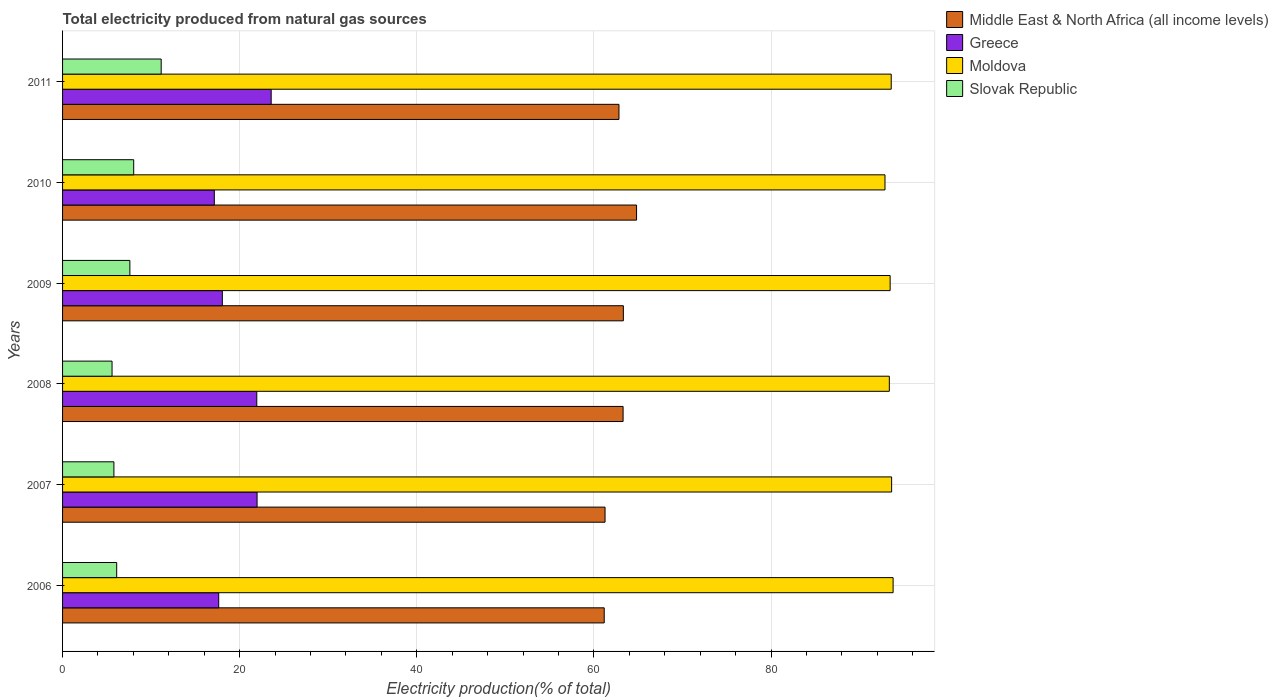How many different coloured bars are there?
Your answer should be very brief. 4. Are the number of bars per tick equal to the number of legend labels?
Your response must be concise. Yes. How many bars are there on the 3rd tick from the top?
Keep it short and to the point. 4. How many bars are there on the 1st tick from the bottom?
Your answer should be compact. 4. In how many cases, is the number of bars for a given year not equal to the number of legend labels?
Your answer should be compact. 0. What is the total electricity produced in Slovak Republic in 2006?
Your answer should be very brief. 6.11. Across all years, what is the maximum total electricity produced in Moldova?
Offer a terse response. 93.78. Across all years, what is the minimum total electricity produced in Middle East & North Africa (all income levels)?
Make the answer very short. 61.16. In which year was the total electricity produced in Greece maximum?
Keep it short and to the point. 2011. In which year was the total electricity produced in Middle East & North Africa (all income levels) minimum?
Your response must be concise. 2006. What is the total total electricity produced in Slovak Republic in the graph?
Your answer should be very brief. 44.27. What is the difference between the total electricity produced in Greece in 2007 and that in 2009?
Provide a succinct answer. 3.92. What is the difference between the total electricity produced in Moldova in 2006 and the total electricity produced in Middle East & North Africa (all income levels) in 2008?
Your response must be concise. 30.49. What is the average total electricity produced in Middle East & North Africa (all income levels) per year?
Offer a terse response. 62.78. In the year 2010, what is the difference between the total electricity produced in Greece and total electricity produced in Moldova?
Give a very brief answer. -75.73. What is the ratio of the total electricity produced in Greece in 2006 to that in 2007?
Ensure brevity in your answer.  0.8. Is the difference between the total electricity produced in Greece in 2007 and 2010 greater than the difference between the total electricity produced in Moldova in 2007 and 2010?
Offer a very short reply. Yes. What is the difference between the highest and the second highest total electricity produced in Middle East & North Africa (all income levels)?
Your response must be concise. 1.49. What is the difference between the highest and the lowest total electricity produced in Moldova?
Provide a short and direct response. 0.92. In how many years, is the total electricity produced in Middle East & North Africa (all income levels) greater than the average total electricity produced in Middle East & North Africa (all income levels) taken over all years?
Offer a very short reply. 4. Is the sum of the total electricity produced in Greece in 2006 and 2008 greater than the maximum total electricity produced in Slovak Republic across all years?
Your answer should be compact. Yes. Is it the case that in every year, the sum of the total electricity produced in Middle East & North Africa (all income levels) and total electricity produced in Moldova is greater than the sum of total electricity produced in Slovak Republic and total electricity produced in Greece?
Provide a succinct answer. No. What does the 1st bar from the top in 2010 represents?
Offer a terse response. Slovak Republic. What does the 1st bar from the bottom in 2007 represents?
Your answer should be very brief. Middle East & North Africa (all income levels). How many bars are there?
Provide a succinct answer. 24. Are the values on the major ticks of X-axis written in scientific E-notation?
Make the answer very short. No. Does the graph contain any zero values?
Offer a terse response. No. Where does the legend appear in the graph?
Make the answer very short. Top right. How are the legend labels stacked?
Ensure brevity in your answer.  Vertical. What is the title of the graph?
Make the answer very short. Total electricity produced from natural gas sources. Does "Syrian Arab Republic" appear as one of the legend labels in the graph?
Your response must be concise. No. What is the label or title of the X-axis?
Offer a very short reply. Electricity production(% of total). What is the Electricity production(% of total) of Middle East & North Africa (all income levels) in 2006?
Give a very brief answer. 61.16. What is the Electricity production(% of total) in Greece in 2006?
Offer a very short reply. 17.63. What is the Electricity production(% of total) in Moldova in 2006?
Offer a very short reply. 93.78. What is the Electricity production(% of total) of Slovak Republic in 2006?
Offer a terse response. 6.11. What is the Electricity production(% of total) of Middle East & North Africa (all income levels) in 2007?
Your answer should be compact. 61.26. What is the Electricity production(% of total) in Greece in 2007?
Offer a terse response. 21.96. What is the Electricity production(% of total) of Moldova in 2007?
Offer a terse response. 93.62. What is the Electricity production(% of total) of Slovak Republic in 2007?
Offer a terse response. 5.8. What is the Electricity production(% of total) in Middle East & North Africa (all income levels) in 2008?
Give a very brief answer. 63.29. What is the Electricity production(% of total) in Greece in 2008?
Offer a very short reply. 21.93. What is the Electricity production(% of total) in Moldova in 2008?
Give a very brief answer. 93.36. What is the Electricity production(% of total) of Slovak Republic in 2008?
Your answer should be very brief. 5.59. What is the Electricity production(% of total) in Middle East & North Africa (all income levels) in 2009?
Give a very brief answer. 63.32. What is the Electricity production(% of total) in Greece in 2009?
Make the answer very short. 18.04. What is the Electricity production(% of total) of Moldova in 2009?
Give a very brief answer. 93.45. What is the Electricity production(% of total) in Slovak Republic in 2009?
Ensure brevity in your answer.  7.6. What is the Electricity production(% of total) of Middle East & North Africa (all income levels) in 2010?
Keep it short and to the point. 64.82. What is the Electricity production(% of total) in Greece in 2010?
Your answer should be compact. 17.14. What is the Electricity production(% of total) in Moldova in 2010?
Provide a short and direct response. 92.87. What is the Electricity production(% of total) in Slovak Republic in 2010?
Make the answer very short. 8.03. What is the Electricity production(% of total) in Middle East & North Africa (all income levels) in 2011?
Keep it short and to the point. 62.83. What is the Electricity production(% of total) in Greece in 2011?
Your response must be concise. 23.56. What is the Electricity production(% of total) of Moldova in 2011?
Your answer should be very brief. 93.57. What is the Electricity production(% of total) in Slovak Republic in 2011?
Give a very brief answer. 11.14. Across all years, what is the maximum Electricity production(% of total) of Middle East & North Africa (all income levels)?
Provide a short and direct response. 64.82. Across all years, what is the maximum Electricity production(% of total) in Greece?
Keep it short and to the point. 23.56. Across all years, what is the maximum Electricity production(% of total) of Moldova?
Ensure brevity in your answer.  93.78. Across all years, what is the maximum Electricity production(% of total) of Slovak Republic?
Give a very brief answer. 11.14. Across all years, what is the minimum Electricity production(% of total) of Middle East & North Africa (all income levels)?
Offer a very short reply. 61.16. Across all years, what is the minimum Electricity production(% of total) of Greece?
Ensure brevity in your answer.  17.14. Across all years, what is the minimum Electricity production(% of total) in Moldova?
Keep it short and to the point. 92.87. Across all years, what is the minimum Electricity production(% of total) in Slovak Republic?
Provide a short and direct response. 5.59. What is the total Electricity production(% of total) of Middle East & North Africa (all income levels) in the graph?
Your answer should be very brief. 376.68. What is the total Electricity production(% of total) of Greece in the graph?
Give a very brief answer. 120.26. What is the total Electricity production(% of total) of Moldova in the graph?
Your response must be concise. 560.65. What is the total Electricity production(% of total) of Slovak Republic in the graph?
Give a very brief answer. 44.27. What is the difference between the Electricity production(% of total) of Middle East & North Africa (all income levels) in 2006 and that in 2007?
Ensure brevity in your answer.  -0.09. What is the difference between the Electricity production(% of total) of Greece in 2006 and that in 2007?
Provide a short and direct response. -4.33. What is the difference between the Electricity production(% of total) in Moldova in 2006 and that in 2007?
Provide a succinct answer. 0.17. What is the difference between the Electricity production(% of total) in Slovak Republic in 2006 and that in 2007?
Provide a succinct answer. 0.31. What is the difference between the Electricity production(% of total) of Middle East & North Africa (all income levels) in 2006 and that in 2008?
Keep it short and to the point. -2.13. What is the difference between the Electricity production(% of total) of Greece in 2006 and that in 2008?
Your response must be concise. -4.3. What is the difference between the Electricity production(% of total) in Moldova in 2006 and that in 2008?
Your answer should be compact. 0.43. What is the difference between the Electricity production(% of total) in Slovak Republic in 2006 and that in 2008?
Your response must be concise. 0.52. What is the difference between the Electricity production(% of total) in Middle East & North Africa (all income levels) in 2006 and that in 2009?
Your answer should be compact. -2.16. What is the difference between the Electricity production(% of total) of Greece in 2006 and that in 2009?
Ensure brevity in your answer.  -0.41. What is the difference between the Electricity production(% of total) in Moldova in 2006 and that in 2009?
Your response must be concise. 0.33. What is the difference between the Electricity production(% of total) in Slovak Republic in 2006 and that in 2009?
Provide a succinct answer. -1.49. What is the difference between the Electricity production(% of total) in Middle East & North Africa (all income levels) in 2006 and that in 2010?
Your answer should be very brief. -3.65. What is the difference between the Electricity production(% of total) in Greece in 2006 and that in 2010?
Offer a terse response. 0.5. What is the difference between the Electricity production(% of total) in Moldova in 2006 and that in 2010?
Give a very brief answer. 0.92. What is the difference between the Electricity production(% of total) in Slovak Republic in 2006 and that in 2010?
Your answer should be very brief. -1.92. What is the difference between the Electricity production(% of total) in Middle East & North Africa (all income levels) in 2006 and that in 2011?
Offer a terse response. -1.67. What is the difference between the Electricity production(% of total) in Greece in 2006 and that in 2011?
Give a very brief answer. -5.92. What is the difference between the Electricity production(% of total) of Moldova in 2006 and that in 2011?
Keep it short and to the point. 0.21. What is the difference between the Electricity production(% of total) of Slovak Republic in 2006 and that in 2011?
Your answer should be very brief. -5.02. What is the difference between the Electricity production(% of total) in Middle East & North Africa (all income levels) in 2007 and that in 2008?
Your response must be concise. -2.04. What is the difference between the Electricity production(% of total) of Greece in 2007 and that in 2008?
Your answer should be very brief. 0.03. What is the difference between the Electricity production(% of total) of Moldova in 2007 and that in 2008?
Your response must be concise. 0.26. What is the difference between the Electricity production(% of total) of Slovak Republic in 2007 and that in 2008?
Your answer should be compact. 0.21. What is the difference between the Electricity production(% of total) of Middle East & North Africa (all income levels) in 2007 and that in 2009?
Give a very brief answer. -2.07. What is the difference between the Electricity production(% of total) of Greece in 2007 and that in 2009?
Ensure brevity in your answer.  3.92. What is the difference between the Electricity production(% of total) in Moldova in 2007 and that in 2009?
Your answer should be compact. 0.17. What is the difference between the Electricity production(% of total) in Slovak Republic in 2007 and that in 2009?
Provide a short and direct response. -1.8. What is the difference between the Electricity production(% of total) in Middle East & North Africa (all income levels) in 2007 and that in 2010?
Provide a succinct answer. -3.56. What is the difference between the Electricity production(% of total) of Greece in 2007 and that in 2010?
Give a very brief answer. 4.83. What is the difference between the Electricity production(% of total) of Moldova in 2007 and that in 2010?
Ensure brevity in your answer.  0.75. What is the difference between the Electricity production(% of total) of Slovak Republic in 2007 and that in 2010?
Make the answer very short. -2.23. What is the difference between the Electricity production(% of total) in Middle East & North Africa (all income levels) in 2007 and that in 2011?
Offer a very short reply. -1.57. What is the difference between the Electricity production(% of total) of Greece in 2007 and that in 2011?
Your answer should be compact. -1.59. What is the difference between the Electricity production(% of total) of Moldova in 2007 and that in 2011?
Your answer should be very brief. 0.05. What is the difference between the Electricity production(% of total) of Slovak Republic in 2007 and that in 2011?
Offer a very short reply. -5.34. What is the difference between the Electricity production(% of total) in Middle East & North Africa (all income levels) in 2008 and that in 2009?
Your answer should be very brief. -0.03. What is the difference between the Electricity production(% of total) of Greece in 2008 and that in 2009?
Provide a short and direct response. 3.89. What is the difference between the Electricity production(% of total) in Moldova in 2008 and that in 2009?
Give a very brief answer. -0.09. What is the difference between the Electricity production(% of total) in Slovak Republic in 2008 and that in 2009?
Give a very brief answer. -2.01. What is the difference between the Electricity production(% of total) in Middle East & North Africa (all income levels) in 2008 and that in 2010?
Your response must be concise. -1.52. What is the difference between the Electricity production(% of total) in Greece in 2008 and that in 2010?
Make the answer very short. 4.8. What is the difference between the Electricity production(% of total) in Moldova in 2008 and that in 2010?
Ensure brevity in your answer.  0.49. What is the difference between the Electricity production(% of total) in Slovak Republic in 2008 and that in 2010?
Offer a terse response. -2.44. What is the difference between the Electricity production(% of total) of Middle East & North Africa (all income levels) in 2008 and that in 2011?
Provide a short and direct response. 0.46. What is the difference between the Electricity production(% of total) in Greece in 2008 and that in 2011?
Give a very brief answer. -1.62. What is the difference between the Electricity production(% of total) of Moldova in 2008 and that in 2011?
Keep it short and to the point. -0.21. What is the difference between the Electricity production(% of total) in Slovak Republic in 2008 and that in 2011?
Make the answer very short. -5.55. What is the difference between the Electricity production(% of total) of Middle East & North Africa (all income levels) in 2009 and that in 2010?
Give a very brief answer. -1.49. What is the difference between the Electricity production(% of total) in Greece in 2009 and that in 2010?
Give a very brief answer. 0.91. What is the difference between the Electricity production(% of total) in Moldova in 2009 and that in 2010?
Offer a very short reply. 0.58. What is the difference between the Electricity production(% of total) in Slovak Republic in 2009 and that in 2010?
Provide a short and direct response. -0.43. What is the difference between the Electricity production(% of total) in Middle East & North Africa (all income levels) in 2009 and that in 2011?
Your response must be concise. 0.49. What is the difference between the Electricity production(% of total) of Greece in 2009 and that in 2011?
Provide a succinct answer. -5.51. What is the difference between the Electricity production(% of total) of Moldova in 2009 and that in 2011?
Offer a very short reply. -0.12. What is the difference between the Electricity production(% of total) in Slovak Republic in 2009 and that in 2011?
Provide a short and direct response. -3.53. What is the difference between the Electricity production(% of total) of Middle East & North Africa (all income levels) in 2010 and that in 2011?
Your answer should be very brief. 1.99. What is the difference between the Electricity production(% of total) in Greece in 2010 and that in 2011?
Ensure brevity in your answer.  -6.42. What is the difference between the Electricity production(% of total) in Moldova in 2010 and that in 2011?
Provide a short and direct response. -0.7. What is the difference between the Electricity production(% of total) in Slovak Republic in 2010 and that in 2011?
Provide a short and direct response. -3.1. What is the difference between the Electricity production(% of total) in Middle East & North Africa (all income levels) in 2006 and the Electricity production(% of total) in Greece in 2007?
Offer a terse response. 39.2. What is the difference between the Electricity production(% of total) of Middle East & North Africa (all income levels) in 2006 and the Electricity production(% of total) of Moldova in 2007?
Give a very brief answer. -32.45. What is the difference between the Electricity production(% of total) of Middle East & North Africa (all income levels) in 2006 and the Electricity production(% of total) of Slovak Republic in 2007?
Offer a very short reply. 55.37. What is the difference between the Electricity production(% of total) in Greece in 2006 and the Electricity production(% of total) in Moldova in 2007?
Offer a very short reply. -75.99. What is the difference between the Electricity production(% of total) in Greece in 2006 and the Electricity production(% of total) in Slovak Republic in 2007?
Your answer should be compact. 11.83. What is the difference between the Electricity production(% of total) in Moldova in 2006 and the Electricity production(% of total) in Slovak Republic in 2007?
Your response must be concise. 87.99. What is the difference between the Electricity production(% of total) in Middle East & North Africa (all income levels) in 2006 and the Electricity production(% of total) in Greece in 2008?
Keep it short and to the point. 39.23. What is the difference between the Electricity production(% of total) in Middle East & North Africa (all income levels) in 2006 and the Electricity production(% of total) in Moldova in 2008?
Your answer should be compact. -32.19. What is the difference between the Electricity production(% of total) of Middle East & North Africa (all income levels) in 2006 and the Electricity production(% of total) of Slovak Republic in 2008?
Keep it short and to the point. 55.58. What is the difference between the Electricity production(% of total) in Greece in 2006 and the Electricity production(% of total) in Moldova in 2008?
Ensure brevity in your answer.  -75.73. What is the difference between the Electricity production(% of total) in Greece in 2006 and the Electricity production(% of total) in Slovak Republic in 2008?
Your answer should be compact. 12.04. What is the difference between the Electricity production(% of total) of Moldova in 2006 and the Electricity production(% of total) of Slovak Republic in 2008?
Give a very brief answer. 88.2. What is the difference between the Electricity production(% of total) in Middle East & North Africa (all income levels) in 2006 and the Electricity production(% of total) in Greece in 2009?
Offer a terse response. 43.12. What is the difference between the Electricity production(% of total) of Middle East & North Africa (all income levels) in 2006 and the Electricity production(% of total) of Moldova in 2009?
Your response must be concise. -32.29. What is the difference between the Electricity production(% of total) in Middle East & North Africa (all income levels) in 2006 and the Electricity production(% of total) in Slovak Republic in 2009?
Your response must be concise. 53.56. What is the difference between the Electricity production(% of total) in Greece in 2006 and the Electricity production(% of total) in Moldova in 2009?
Keep it short and to the point. -75.82. What is the difference between the Electricity production(% of total) of Greece in 2006 and the Electricity production(% of total) of Slovak Republic in 2009?
Your response must be concise. 10.03. What is the difference between the Electricity production(% of total) of Moldova in 2006 and the Electricity production(% of total) of Slovak Republic in 2009?
Keep it short and to the point. 86.18. What is the difference between the Electricity production(% of total) of Middle East & North Africa (all income levels) in 2006 and the Electricity production(% of total) of Greece in 2010?
Your answer should be very brief. 44.03. What is the difference between the Electricity production(% of total) of Middle East & North Africa (all income levels) in 2006 and the Electricity production(% of total) of Moldova in 2010?
Keep it short and to the point. -31.7. What is the difference between the Electricity production(% of total) in Middle East & North Africa (all income levels) in 2006 and the Electricity production(% of total) in Slovak Republic in 2010?
Ensure brevity in your answer.  53.13. What is the difference between the Electricity production(% of total) in Greece in 2006 and the Electricity production(% of total) in Moldova in 2010?
Offer a terse response. -75.24. What is the difference between the Electricity production(% of total) in Greece in 2006 and the Electricity production(% of total) in Slovak Republic in 2010?
Provide a succinct answer. 9.6. What is the difference between the Electricity production(% of total) of Moldova in 2006 and the Electricity production(% of total) of Slovak Republic in 2010?
Offer a terse response. 85.75. What is the difference between the Electricity production(% of total) in Middle East & North Africa (all income levels) in 2006 and the Electricity production(% of total) in Greece in 2011?
Make the answer very short. 37.61. What is the difference between the Electricity production(% of total) of Middle East & North Africa (all income levels) in 2006 and the Electricity production(% of total) of Moldova in 2011?
Your answer should be very brief. -32.41. What is the difference between the Electricity production(% of total) of Middle East & North Africa (all income levels) in 2006 and the Electricity production(% of total) of Slovak Republic in 2011?
Ensure brevity in your answer.  50.03. What is the difference between the Electricity production(% of total) of Greece in 2006 and the Electricity production(% of total) of Moldova in 2011?
Provide a succinct answer. -75.94. What is the difference between the Electricity production(% of total) of Greece in 2006 and the Electricity production(% of total) of Slovak Republic in 2011?
Ensure brevity in your answer.  6.5. What is the difference between the Electricity production(% of total) in Moldova in 2006 and the Electricity production(% of total) in Slovak Republic in 2011?
Give a very brief answer. 82.65. What is the difference between the Electricity production(% of total) of Middle East & North Africa (all income levels) in 2007 and the Electricity production(% of total) of Greece in 2008?
Give a very brief answer. 39.33. What is the difference between the Electricity production(% of total) of Middle East & North Africa (all income levels) in 2007 and the Electricity production(% of total) of Moldova in 2008?
Keep it short and to the point. -32.1. What is the difference between the Electricity production(% of total) in Middle East & North Africa (all income levels) in 2007 and the Electricity production(% of total) in Slovak Republic in 2008?
Ensure brevity in your answer.  55.67. What is the difference between the Electricity production(% of total) in Greece in 2007 and the Electricity production(% of total) in Moldova in 2008?
Give a very brief answer. -71.39. What is the difference between the Electricity production(% of total) of Greece in 2007 and the Electricity production(% of total) of Slovak Republic in 2008?
Offer a terse response. 16.38. What is the difference between the Electricity production(% of total) in Moldova in 2007 and the Electricity production(% of total) in Slovak Republic in 2008?
Your response must be concise. 88.03. What is the difference between the Electricity production(% of total) of Middle East & North Africa (all income levels) in 2007 and the Electricity production(% of total) of Greece in 2009?
Your answer should be compact. 43.21. What is the difference between the Electricity production(% of total) of Middle East & North Africa (all income levels) in 2007 and the Electricity production(% of total) of Moldova in 2009?
Your answer should be compact. -32.19. What is the difference between the Electricity production(% of total) in Middle East & North Africa (all income levels) in 2007 and the Electricity production(% of total) in Slovak Republic in 2009?
Ensure brevity in your answer.  53.66. What is the difference between the Electricity production(% of total) in Greece in 2007 and the Electricity production(% of total) in Moldova in 2009?
Provide a succinct answer. -71.49. What is the difference between the Electricity production(% of total) of Greece in 2007 and the Electricity production(% of total) of Slovak Republic in 2009?
Give a very brief answer. 14.36. What is the difference between the Electricity production(% of total) of Moldova in 2007 and the Electricity production(% of total) of Slovak Republic in 2009?
Provide a short and direct response. 86.02. What is the difference between the Electricity production(% of total) in Middle East & North Africa (all income levels) in 2007 and the Electricity production(% of total) in Greece in 2010?
Your answer should be very brief. 44.12. What is the difference between the Electricity production(% of total) in Middle East & North Africa (all income levels) in 2007 and the Electricity production(% of total) in Moldova in 2010?
Ensure brevity in your answer.  -31.61. What is the difference between the Electricity production(% of total) in Middle East & North Africa (all income levels) in 2007 and the Electricity production(% of total) in Slovak Republic in 2010?
Give a very brief answer. 53.22. What is the difference between the Electricity production(% of total) of Greece in 2007 and the Electricity production(% of total) of Moldova in 2010?
Your answer should be compact. -70.9. What is the difference between the Electricity production(% of total) in Greece in 2007 and the Electricity production(% of total) in Slovak Republic in 2010?
Ensure brevity in your answer.  13.93. What is the difference between the Electricity production(% of total) of Moldova in 2007 and the Electricity production(% of total) of Slovak Republic in 2010?
Give a very brief answer. 85.58. What is the difference between the Electricity production(% of total) in Middle East & North Africa (all income levels) in 2007 and the Electricity production(% of total) in Greece in 2011?
Your answer should be compact. 37.7. What is the difference between the Electricity production(% of total) of Middle East & North Africa (all income levels) in 2007 and the Electricity production(% of total) of Moldova in 2011?
Offer a terse response. -32.31. What is the difference between the Electricity production(% of total) of Middle East & North Africa (all income levels) in 2007 and the Electricity production(% of total) of Slovak Republic in 2011?
Your answer should be compact. 50.12. What is the difference between the Electricity production(% of total) in Greece in 2007 and the Electricity production(% of total) in Moldova in 2011?
Offer a very short reply. -71.61. What is the difference between the Electricity production(% of total) in Greece in 2007 and the Electricity production(% of total) in Slovak Republic in 2011?
Keep it short and to the point. 10.83. What is the difference between the Electricity production(% of total) of Moldova in 2007 and the Electricity production(% of total) of Slovak Republic in 2011?
Offer a very short reply. 82.48. What is the difference between the Electricity production(% of total) of Middle East & North Africa (all income levels) in 2008 and the Electricity production(% of total) of Greece in 2009?
Ensure brevity in your answer.  45.25. What is the difference between the Electricity production(% of total) in Middle East & North Africa (all income levels) in 2008 and the Electricity production(% of total) in Moldova in 2009?
Your response must be concise. -30.16. What is the difference between the Electricity production(% of total) of Middle East & North Africa (all income levels) in 2008 and the Electricity production(% of total) of Slovak Republic in 2009?
Provide a short and direct response. 55.69. What is the difference between the Electricity production(% of total) of Greece in 2008 and the Electricity production(% of total) of Moldova in 2009?
Provide a short and direct response. -71.52. What is the difference between the Electricity production(% of total) in Greece in 2008 and the Electricity production(% of total) in Slovak Republic in 2009?
Provide a succinct answer. 14.33. What is the difference between the Electricity production(% of total) in Moldova in 2008 and the Electricity production(% of total) in Slovak Republic in 2009?
Make the answer very short. 85.76. What is the difference between the Electricity production(% of total) in Middle East & North Africa (all income levels) in 2008 and the Electricity production(% of total) in Greece in 2010?
Your answer should be very brief. 46.16. What is the difference between the Electricity production(% of total) in Middle East & North Africa (all income levels) in 2008 and the Electricity production(% of total) in Moldova in 2010?
Your answer should be very brief. -29.57. What is the difference between the Electricity production(% of total) in Middle East & North Africa (all income levels) in 2008 and the Electricity production(% of total) in Slovak Republic in 2010?
Offer a very short reply. 55.26. What is the difference between the Electricity production(% of total) of Greece in 2008 and the Electricity production(% of total) of Moldova in 2010?
Provide a short and direct response. -70.94. What is the difference between the Electricity production(% of total) in Greece in 2008 and the Electricity production(% of total) in Slovak Republic in 2010?
Your answer should be compact. 13.9. What is the difference between the Electricity production(% of total) of Moldova in 2008 and the Electricity production(% of total) of Slovak Republic in 2010?
Your answer should be very brief. 85.33. What is the difference between the Electricity production(% of total) of Middle East & North Africa (all income levels) in 2008 and the Electricity production(% of total) of Greece in 2011?
Your answer should be very brief. 39.74. What is the difference between the Electricity production(% of total) in Middle East & North Africa (all income levels) in 2008 and the Electricity production(% of total) in Moldova in 2011?
Make the answer very short. -30.28. What is the difference between the Electricity production(% of total) in Middle East & North Africa (all income levels) in 2008 and the Electricity production(% of total) in Slovak Republic in 2011?
Your answer should be compact. 52.16. What is the difference between the Electricity production(% of total) in Greece in 2008 and the Electricity production(% of total) in Moldova in 2011?
Your answer should be very brief. -71.64. What is the difference between the Electricity production(% of total) of Greece in 2008 and the Electricity production(% of total) of Slovak Republic in 2011?
Keep it short and to the point. 10.8. What is the difference between the Electricity production(% of total) of Moldova in 2008 and the Electricity production(% of total) of Slovak Republic in 2011?
Give a very brief answer. 82.22. What is the difference between the Electricity production(% of total) of Middle East & North Africa (all income levels) in 2009 and the Electricity production(% of total) of Greece in 2010?
Provide a succinct answer. 46.19. What is the difference between the Electricity production(% of total) in Middle East & North Africa (all income levels) in 2009 and the Electricity production(% of total) in Moldova in 2010?
Keep it short and to the point. -29.54. What is the difference between the Electricity production(% of total) of Middle East & North Africa (all income levels) in 2009 and the Electricity production(% of total) of Slovak Republic in 2010?
Keep it short and to the point. 55.29. What is the difference between the Electricity production(% of total) of Greece in 2009 and the Electricity production(% of total) of Moldova in 2010?
Provide a short and direct response. -74.83. What is the difference between the Electricity production(% of total) of Greece in 2009 and the Electricity production(% of total) of Slovak Republic in 2010?
Offer a very short reply. 10.01. What is the difference between the Electricity production(% of total) of Moldova in 2009 and the Electricity production(% of total) of Slovak Republic in 2010?
Keep it short and to the point. 85.42. What is the difference between the Electricity production(% of total) of Middle East & North Africa (all income levels) in 2009 and the Electricity production(% of total) of Greece in 2011?
Keep it short and to the point. 39.77. What is the difference between the Electricity production(% of total) in Middle East & North Africa (all income levels) in 2009 and the Electricity production(% of total) in Moldova in 2011?
Ensure brevity in your answer.  -30.25. What is the difference between the Electricity production(% of total) of Middle East & North Africa (all income levels) in 2009 and the Electricity production(% of total) of Slovak Republic in 2011?
Ensure brevity in your answer.  52.19. What is the difference between the Electricity production(% of total) of Greece in 2009 and the Electricity production(% of total) of Moldova in 2011?
Make the answer very short. -75.53. What is the difference between the Electricity production(% of total) in Greece in 2009 and the Electricity production(% of total) in Slovak Republic in 2011?
Provide a succinct answer. 6.91. What is the difference between the Electricity production(% of total) of Moldova in 2009 and the Electricity production(% of total) of Slovak Republic in 2011?
Offer a very short reply. 82.31. What is the difference between the Electricity production(% of total) of Middle East & North Africa (all income levels) in 2010 and the Electricity production(% of total) of Greece in 2011?
Make the answer very short. 41.26. What is the difference between the Electricity production(% of total) in Middle East & North Africa (all income levels) in 2010 and the Electricity production(% of total) in Moldova in 2011?
Keep it short and to the point. -28.75. What is the difference between the Electricity production(% of total) of Middle East & North Africa (all income levels) in 2010 and the Electricity production(% of total) of Slovak Republic in 2011?
Ensure brevity in your answer.  53.68. What is the difference between the Electricity production(% of total) in Greece in 2010 and the Electricity production(% of total) in Moldova in 2011?
Offer a very short reply. -76.44. What is the difference between the Electricity production(% of total) in Greece in 2010 and the Electricity production(% of total) in Slovak Republic in 2011?
Offer a very short reply. 6. What is the difference between the Electricity production(% of total) in Moldova in 2010 and the Electricity production(% of total) in Slovak Republic in 2011?
Ensure brevity in your answer.  81.73. What is the average Electricity production(% of total) in Middle East & North Africa (all income levels) per year?
Keep it short and to the point. 62.78. What is the average Electricity production(% of total) of Greece per year?
Offer a terse response. 20.04. What is the average Electricity production(% of total) of Moldova per year?
Give a very brief answer. 93.44. What is the average Electricity production(% of total) of Slovak Republic per year?
Provide a short and direct response. 7.38. In the year 2006, what is the difference between the Electricity production(% of total) in Middle East & North Africa (all income levels) and Electricity production(% of total) in Greece?
Offer a terse response. 43.53. In the year 2006, what is the difference between the Electricity production(% of total) in Middle East & North Africa (all income levels) and Electricity production(% of total) in Moldova?
Give a very brief answer. -32.62. In the year 2006, what is the difference between the Electricity production(% of total) of Middle East & North Africa (all income levels) and Electricity production(% of total) of Slovak Republic?
Ensure brevity in your answer.  55.05. In the year 2006, what is the difference between the Electricity production(% of total) of Greece and Electricity production(% of total) of Moldova?
Make the answer very short. -76.15. In the year 2006, what is the difference between the Electricity production(% of total) of Greece and Electricity production(% of total) of Slovak Republic?
Make the answer very short. 11.52. In the year 2006, what is the difference between the Electricity production(% of total) in Moldova and Electricity production(% of total) in Slovak Republic?
Give a very brief answer. 87.67. In the year 2007, what is the difference between the Electricity production(% of total) in Middle East & North Africa (all income levels) and Electricity production(% of total) in Greece?
Give a very brief answer. 39.29. In the year 2007, what is the difference between the Electricity production(% of total) in Middle East & North Africa (all income levels) and Electricity production(% of total) in Moldova?
Ensure brevity in your answer.  -32.36. In the year 2007, what is the difference between the Electricity production(% of total) in Middle East & North Africa (all income levels) and Electricity production(% of total) in Slovak Republic?
Ensure brevity in your answer.  55.46. In the year 2007, what is the difference between the Electricity production(% of total) of Greece and Electricity production(% of total) of Moldova?
Keep it short and to the point. -71.65. In the year 2007, what is the difference between the Electricity production(% of total) of Greece and Electricity production(% of total) of Slovak Republic?
Give a very brief answer. 16.17. In the year 2007, what is the difference between the Electricity production(% of total) in Moldova and Electricity production(% of total) in Slovak Republic?
Keep it short and to the point. 87.82. In the year 2008, what is the difference between the Electricity production(% of total) in Middle East & North Africa (all income levels) and Electricity production(% of total) in Greece?
Keep it short and to the point. 41.36. In the year 2008, what is the difference between the Electricity production(% of total) of Middle East & North Africa (all income levels) and Electricity production(% of total) of Moldova?
Provide a succinct answer. -30.06. In the year 2008, what is the difference between the Electricity production(% of total) in Middle East & North Africa (all income levels) and Electricity production(% of total) in Slovak Republic?
Your answer should be very brief. 57.71. In the year 2008, what is the difference between the Electricity production(% of total) of Greece and Electricity production(% of total) of Moldova?
Your response must be concise. -71.43. In the year 2008, what is the difference between the Electricity production(% of total) of Greece and Electricity production(% of total) of Slovak Republic?
Offer a very short reply. 16.34. In the year 2008, what is the difference between the Electricity production(% of total) of Moldova and Electricity production(% of total) of Slovak Republic?
Your answer should be very brief. 87.77. In the year 2009, what is the difference between the Electricity production(% of total) of Middle East & North Africa (all income levels) and Electricity production(% of total) of Greece?
Keep it short and to the point. 45.28. In the year 2009, what is the difference between the Electricity production(% of total) in Middle East & North Africa (all income levels) and Electricity production(% of total) in Moldova?
Give a very brief answer. -30.13. In the year 2009, what is the difference between the Electricity production(% of total) of Middle East & North Africa (all income levels) and Electricity production(% of total) of Slovak Republic?
Your response must be concise. 55.72. In the year 2009, what is the difference between the Electricity production(% of total) in Greece and Electricity production(% of total) in Moldova?
Your response must be concise. -75.41. In the year 2009, what is the difference between the Electricity production(% of total) of Greece and Electricity production(% of total) of Slovak Republic?
Your answer should be very brief. 10.44. In the year 2009, what is the difference between the Electricity production(% of total) of Moldova and Electricity production(% of total) of Slovak Republic?
Keep it short and to the point. 85.85. In the year 2010, what is the difference between the Electricity production(% of total) of Middle East & North Africa (all income levels) and Electricity production(% of total) of Greece?
Provide a succinct answer. 47.68. In the year 2010, what is the difference between the Electricity production(% of total) in Middle East & North Africa (all income levels) and Electricity production(% of total) in Moldova?
Your answer should be compact. -28.05. In the year 2010, what is the difference between the Electricity production(% of total) of Middle East & North Africa (all income levels) and Electricity production(% of total) of Slovak Republic?
Make the answer very short. 56.78. In the year 2010, what is the difference between the Electricity production(% of total) of Greece and Electricity production(% of total) of Moldova?
Make the answer very short. -75.73. In the year 2010, what is the difference between the Electricity production(% of total) in Greece and Electricity production(% of total) in Slovak Republic?
Provide a short and direct response. 9.1. In the year 2010, what is the difference between the Electricity production(% of total) in Moldova and Electricity production(% of total) in Slovak Republic?
Give a very brief answer. 84.84. In the year 2011, what is the difference between the Electricity production(% of total) in Middle East & North Africa (all income levels) and Electricity production(% of total) in Greece?
Ensure brevity in your answer.  39.27. In the year 2011, what is the difference between the Electricity production(% of total) of Middle East & North Africa (all income levels) and Electricity production(% of total) of Moldova?
Your response must be concise. -30.74. In the year 2011, what is the difference between the Electricity production(% of total) in Middle East & North Africa (all income levels) and Electricity production(% of total) in Slovak Republic?
Your answer should be very brief. 51.69. In the year 2011, what is the difference between the Electricity production(% of total) in Greece and Electricity production(% of total) in Moldova?
Give a very brief answer. -70.02. In the year 2011, what is the difference between the Electricity production(% of total) in Greece and Electricity production(% of total) in Slovak Republic?
Make the answer very short. 12.42. In the year 2011, what is the difference between the Electricity production(% of total) of Moldova and Electricity production(% of total) of Slovak Republic?
Provide a succinct answer. 82.44. What is the ratio of the Electricity production(% of total) in Greece in 2006 to that in 2007?
Your response must be concise. 0.8. What is the ratio of the Electricity production(% of total) in Moldova in 2006 to that in 2007?
Give a very brief answer. 1. What is the ratio of the Electricity production(% of total) of Slovak Republic in 2006 to that in 2007?
Your response must be concise. 1.05. What is the ratio of the Electricity production(% of total) in Middle East & North Africa (all income levels) in 2006 to that in 2008?
Keep it short and to the point. 0.97. What is the ratio of the Electricity production(% of total) of Greece in 2006 to that in 2008?
Ensure brevity in your answer.  0.8. What is the ratio of the Electricity production(% of total) in Moldova in 2006 to that in 2008?
Offer a terse response. 1. What is the ratio of the Electricity production(% of total) in Slovak Republic in 2006 to that in 2008?
Offer a very short reply. 1.09. What is the ratio of the Electricity production(% of total) in Middle East & North Africa (all income levels) in 2006 to that in 2009?
Offer a very short reply. 0.97. What is the ratio of the Electricity production(% of total) of Greece in 2006 to that in 2009?
Provide a succinct answer. 0.98. What is the ratio of the Electricity production(% of total) of Moldova in 2006 to that in 2009?
Keep it short and to the point. 1. What is the ratio of the Electricity production(% of total) of Slovak Republic in 2006 to that in 2009?
Offer a terse response. 0.8. What is the ratio of the Electricity production(% of total) of Middle East & North Africa (all income levels) in 2006 to that in 2010?
Your response must be concise. 0.94. What is the ratio of the Electricity production(% of total) of Greece in 2006 to that in 2010?
Your response must be concise. 1.03. What is the ratio of the Electricity production(% of total) of Moldova in 2006 to that in 2010?
Your answer should be compact. 1.01. What is the ratio of the Electricity production(% of total) of Slovak Republic in 2006 to that in 2010?
Your response must be concise. 0.76. What is the ratio of the Electricity production(% of total) of Middle East & North Africa (all income levels) in 2006 to that in 2011?
Your answer should be compact. 0.97. What is the ratio of the Electricity production(% of total) of Greece in 2006 to that in 2011?
Your answer should be very brief. 0.75. What is the ratio of the Electricity production(% of total) of Moldova in 2006 to that in 2011?
Your response must be concise. 1. What is the ratio of the Electricity production(% of total) in Slovak Republic in 2006 to that in 2011?
Make the answer very short. 0.55. What is the ratio of the Electricity production(% of total) of Middle East & North Africa (all income levels) in 2007 to that in 2008?
Offer a terse response. 0.97. What is the ratio of the Electricity production(% of total) in Greece in 2007 to that in 2008?
Give a very brief answer. 1. What is the ratio of the Electricity production(% of total) of Moldova in 2007 to that in 2008?
Your answer should be very brief. 1. What is the ratio of the Electricity production(% of total) in Slovak Republic in 2007 to that in 2008?
Your answer should be compact. 1.04. What is the ratio of the Electricity production(% of total) in Middle East & North Africa (all income levels) in 2007 to that in 2009?
Your answer should be compact. 0.97. What is the ratio of the Electricity production(% of total) of Greece in 2007 to that in 2009?
Your answer should be very brief. 1.22. What is the ratio of the Electricity production(% of total) of Slovak Republic in 2007 to that in 2009?
Offer a very short reply. 0.76. What is the ratio of the Electricity production(% of total) in Middle East & North Africa (all income levels) in 2007 to that in 2010?
Your answer should be very brief. 0.95. What is the ratio of the Electricity production(% of total) of Greece in 2007 to that in 2010?
Keep it short and to the point. 1.28. What is the ratio of the Electricity production(% of total) in Moldova in 2007 to that in 2010?
Provide a short and direct response. 1.01. What is the ratio of the Electricity production(% of total) of Slovak Republic in 2007 to that in 2010?
Ensure brevity in your answer.  0.72. What is the ratio of the Electricity production(% of total) of Greece in 2007 to that in 2011?
Offer a very short reply. 0.93. What is the ratio of the Electricity production(% of total) in Moldova in 2007 to that in 2011?
Give a very brief answer. 1. What is the ratio of the Electricity production(% of total) of Slovak Republic in 2007 to that in 2011?
Keep it short and to the point. 0.52. What is the ratio of the Electricity production(% of total) of Middle East & North Africa (all income levels) in 2008 to that in 2009?
Provide a succinct answer. 1. What is the ratio of the Electricity production(% of total) of Greece in 2008 to that in 2009?
Provide a short and direct response. 1.22. What is the ratio of the Electricity production(% of total) of Slovak Republic in 2008 to that in 2009?
Ensure brevity in your answer.  0.74. What is the ratio of the Electricity production(% of total) in Middle East & North Africa (all income levels) in 2008 to that in 2010?
Offer a very short reply. 0.98. What is the ratio of the Electricity production(% of total) in Greece in 2008 to that in 2010?
Provide a short and direct response. 1.28. What is the ratio of the Electricity production(% of total) of Moldova in 2008 to that in 2010?
Ensure brevity in your answer.  1.01. What is the ratio of the Electricity production(% of total) in Slovak Republic in 2008 to that in 2010?
Offer a very short reply. 0.7. What is the ratio of the Electricity production(% of total) in Middle East & North Africa (all income levels) in 2008 to that in 2011?
Make the answer very short. 1.01. What is the ratio of the Electricity production(% of total) in Greece in 2008 to that in 2011?
Your answer should be compact. 0.93. What is the ratio of the Electricity production(% of total) of Slovak Republic in 2008 to that in 2011?
Your response must be concise. 0.5. What is the ratio of the Electricity production(% of total) in Middle East & North Africa (all income levels) in 2009 to that in 2010?
Your answer should be compact. 0.98. What is the ratio of the Electricity production(% of total) in Greece in 2009 to that in 2010?
Your response must be concise. 1.05. What is the ratio of the Electricity production(% of total) of Slovak Republic in 2009 to that in 2010?
Provide a succinct answer. 0.95. What is the ratio of the Electricity production(% of total) in Middle East & North Africa (all income levels) in 2009 to that in 2011?
Keep it short and to the point. 1.01. What is the ratio of the Electricity production(% of total) in Greece in 2009 to that in 2011?
Your response must be concise. 0.77. What is the ratio of the Electricity production(% of total) of Moldova in 2009 to that in 2011?
Your answer should be compact. 1. What is the ratio of the Electricity production(% of total) in Slovak Republic in 2009 to that in 2011?
Offer a very short reply. 0.68. What is the ratio of the Electricity production(% of total) in Middle East & North Africa (all income levels) in 2010 to that in 2011?
Offer a very short reply. 1.03. What is the ratio of the Electricity production(% of total) in Greece in 2010 to that in 2011?
Offer a very short reply. 0.73. What is the ratio of the Electricity production(% of total) of Moldova in 2010 to that in 2011?
Give a very brief answer. 0.99. What is the ratio of the Electricity production(% of total) of Slovak Republic in 2010 to that in 2011?
Offer a very short reply. 0.72. What is the difference between the highest and the second highest Electricity production(% of total) of Middle East & North Africa (all income levels)?
Your response must be concise. 1.49. What is the difference between the highest and the second highest Electricity production(% of total) of Greece?
Provide a succinct answer. 1.59. What is the difference between the highest and the second highest Electricity production(% of total) of Moldova?
Make the answer very short. 0.17. What is the difference between the highest and the second highest Electricity production(% of total) in Slovak Republic?
Your answer should be very brief. 3.1. What is the difference between the highest and the lowest Electricity production(% of total) of Middle East & North Africa (all income levels)?
Your answer should be very brief. 3.65. What is the difference between the highest and the lowest Electricity production(% of total) in Greece?
Provide a succinct answer. 6.42. What is the difference between the highest and the lowest Electricity production(% of total) of Moldova?
Your answer should be compact. 0.92. What is the difference between the highest and the lowest Electricity production(% of total) in Slovak Republic?
Keep it short and to the point. 5.55. 